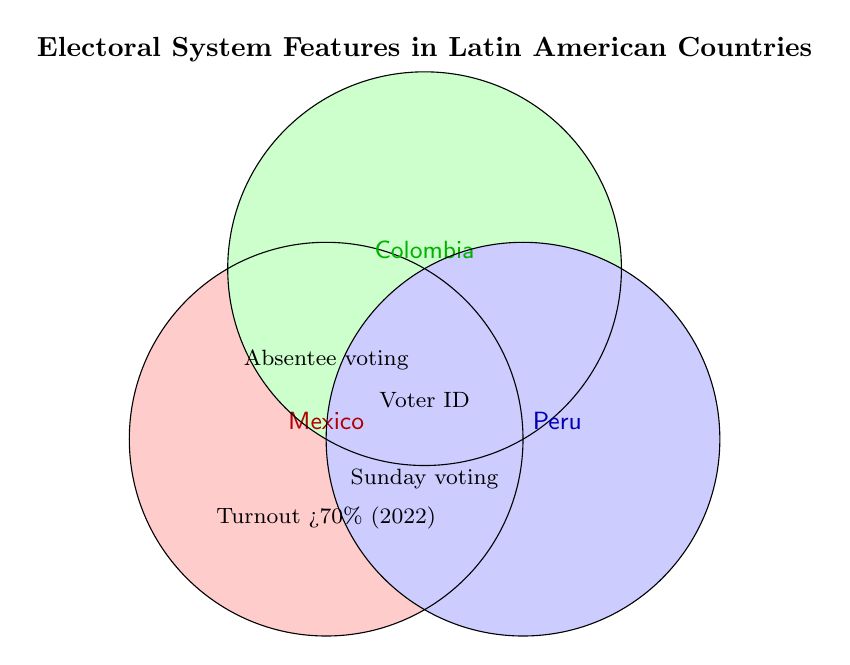What countries have voter IDs required for voting? The Venn Diagram indicates voter ID requirements in the intersection area common to Mexico, Colombia, and Peru. This area shows that all three countries require voter IDs for voting.
Answer: Mexico, Colombia, and Peru Where is absentee voting allowed? The section labeled "Absentee voting" is located in the overlapping area between two sets representing Mexico and Colombia. This indicates absentee voting is allowed in both Mexico and Colombia.
Answer: Mexico and Colombia Which country had a voter turnout rate greater than 70% in 2022? The specific text "Turnout >70% (2022)" is shown within the Mexico circle. Thus, it applies to Mexico.
Answer: Mexico What feature is common to all three countries? The figure shows that the areas common to all three circles (Mexico, Colombia, and Peru) include "Voter ID required" and "Sunday voting."
Answer: Voter ID required and Sunday voting Is absentee voting allowed in Peru? The "Absentee voting" text is not in the Peru circle nor in any space overlapping with Peru, indicating that absentee voting is not allowed in Peru.
Answer: No Which features are unique to Mexico? The unique section for Mexico (not overlapping with any other circles) contains the text "Turnout >70% (2022)."
Answer: Turnout >70% (2022) Are there any features that apply only to Colombia and Peru but not to Mexico? The chart does not have any specific label exclusive to the overlap between only Colombia and Peru, indicating there are no such shared features.
Answer: No How many features does Mexico share with Peru? By examining the areas overlapping between Mexico and Peru, we can see that there is no specific feature listed that applies only to Mexico and Peru together.
Answer: None Is "Sunday voting" allowed in Colombia? "Sunday voting" appears in areas where Mexico, Colombia, and Peru overlap, indicating that it is allowed in Colombia.
Answer: Yes How many features are shared among all three countries? The areas common to all three circles show "Voter ID required" and "Sunday voting", indicating two shared features.
Answer: Two 